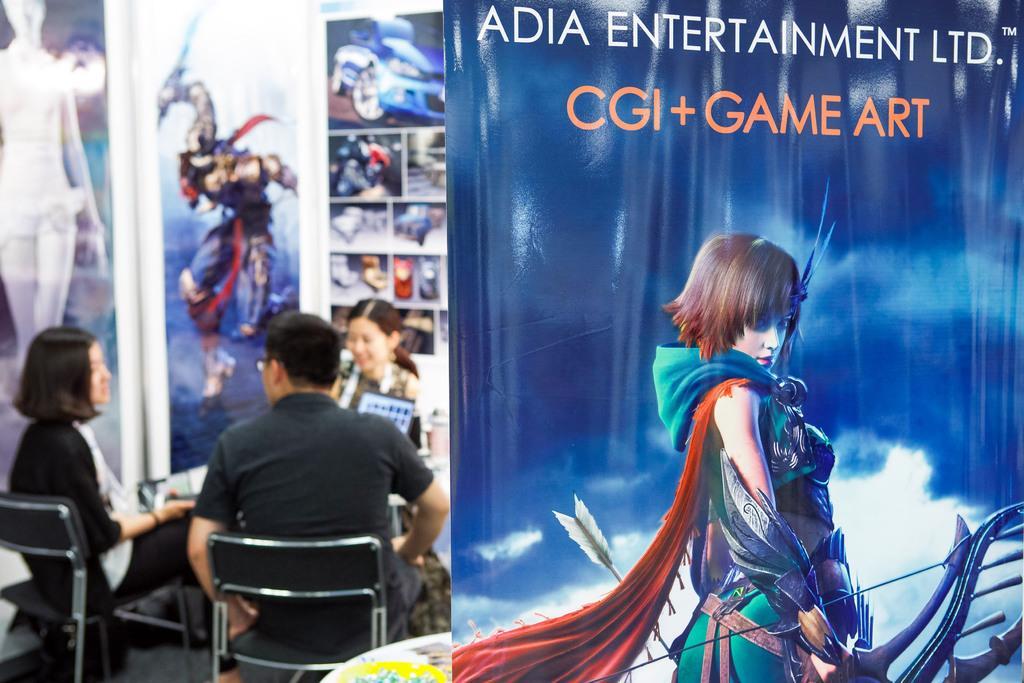Describe this image in one or two sentences. This image is clicked in a room. There are three persons in this image. To the left , the woman sitting in a chair is wearing black jacket. In the background, there is a wall on which posters are pasted. To the right, there is a banner in blue color. 